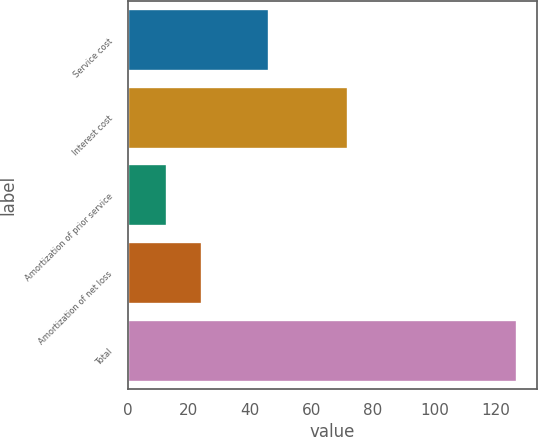Convert chart to OTSL. <chart><loc_0><loc_0><loc_500><loc_500><bar_chart><fcel>Service cost<fcel>Interest cost<fcel>Amortization of prior service<fcel>Amortization of net loss<fcel>Total<nl><fcel>46<fcel>72<fcel>13<fcel>24.4<fcel>127<nl></chart> 